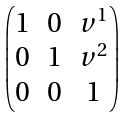<formula> <loc_0><loc_0><loc_500><loc_500>\begin{pmatrix} 1 & 0 & v ^ { 1 } \\ 0 & 1 & v ^ { 2 } \\ 0 & 0 & 1 \end{pmatrix}</formula> 